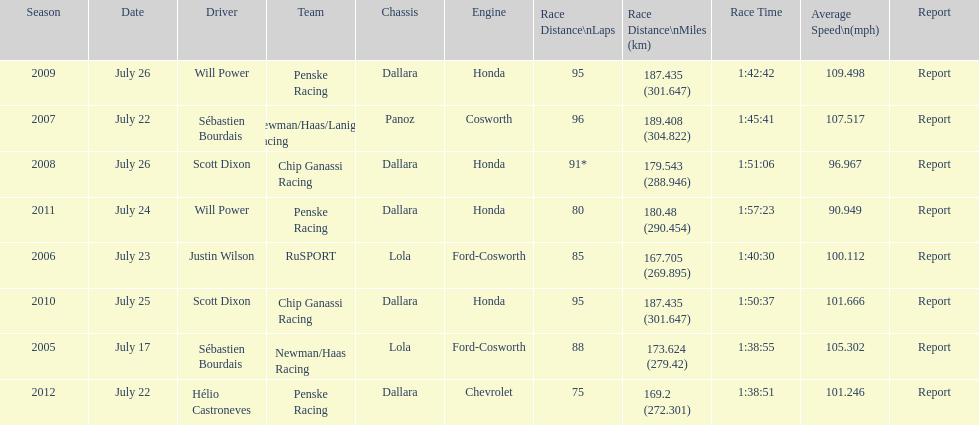Would you be able to parse every entry in this table? {'header': ['Season', 'Date', 'Driver', 'Team', 'Chassis', 'Engine', 'Race Distance\\nLaps', 'Race Distance\\nMiles (km)', 'Race Time', 'Average Speed\\n(mph)', 'Report'], 'rows': [['2009', 'July 26', 'Will Power', 'Penske Racing', 'Dallara', 'Honda', '95', '187.435 (301.647)', '1:42:42', '109.498', 'Report'], ['2007', 'July 22', 'Sébastien Bourdais', 'Newman/Haas/Lanigan Racing', 'Panoz', 'Cosworth', '96', '189.408 (304.822)', '1:45:41', '107.517', 'Report'], ['2008', 'July 26', 'Scott Dixon', 'Chip Ganassi Racing', 'Dallara', 'Honda', '91*', '179.543 (288.946)', '1:51:06', '96.967', 'Report'], ['2011', 'July 24', 'Will Power', 'Penske Racing', 'Dallara', 'Honda', '80', '180.48 (290.454)', '1:57:23', '90.949', 'Report'], ['2006', 'July 23', 'Justin Wilson', 'RuSPORT', 'Lola', 'Ford-Cosworth', '85', '167.705 (269.895)', '1:40:30', '100.112', 'Report'], ['2010', 'July 25', 'Scott Dixon', 'Chip Ganassi Racing', 'Dallara', 'Honda', '95', '187.435 (301.647)', '1:50:37', '101.666', 'Report'], ['2005', 'July 17', 'Sébastien Bourdais', 'Newman/Haas Racing', 'Lola', 'Ford-Cosworth', '88', '173.624 (279.42)', '1:38:55', '105.302', 'Report'], ['2012', 'July 22', 'Hélio Castroneves', 'Penske Racing', 'Dallara', 'Chevrolet', '75', '169.2 (272.301)', '1:38:51', '101.246', 'Report']]} How many times did sébastien bourdais win the champ car world series between 2005 and 2007? 2. 